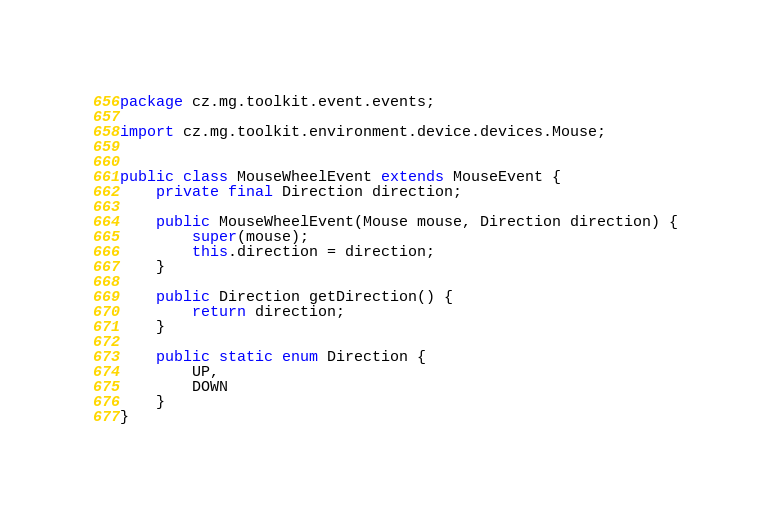Convert code to text. <code><loc_0><loc_0><loc_500><loc_500><_Java_>package cz.mg.toolkit.event.events;

import cz.mg.toolkit.environment.device.devices.Mouse;


public class MouseWheelEvent extends MouseEvent {
    private final Direction direction;

    public MouseWheelEvent(Mouse mouse, Direction direction) {
        super(mouse);
        this.direction = direction;
    }

    public Direction getDirection() {
        return direction;
    }
    
    public static enum Direction {
        UP,
        DOWN
    }
}
</code> 